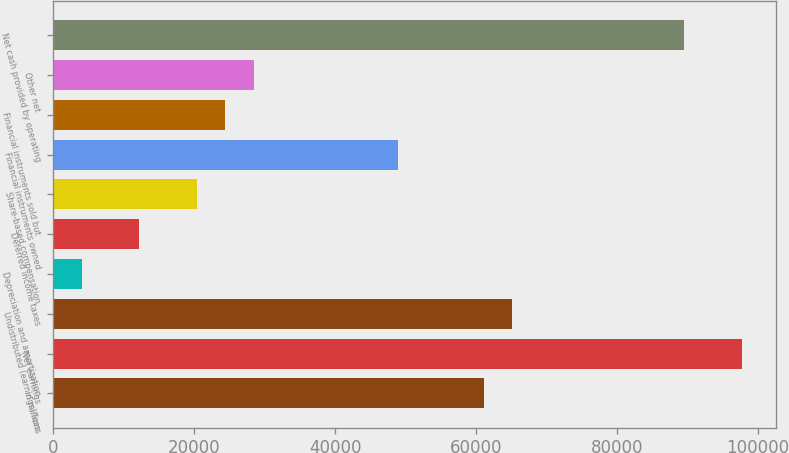Convert chart to OTSL. <chart><loc_0><loc_0><loc_500><loc_500><bar_chart><fcel>in millions<fcel>Net earnings<fcel>Undistributed (earnings)/loss<fcel>Depreciation and amortization<fcel>Deferred income taxes<fcel>Share-based compensation<fcel>Financial instruments owned<fcel>Financial instruments sold but<fcel>Other net<fcel>Net cash provided by operating<nl><fcel>61059<fcel>97690.8<fcel>65129.2<fcel>4076.2<fcel>12216.6<fcel>20357<fcel>48848.4<fcel>24427.2<fcel>28497.4<fcel>89550.4<nl></chart> 